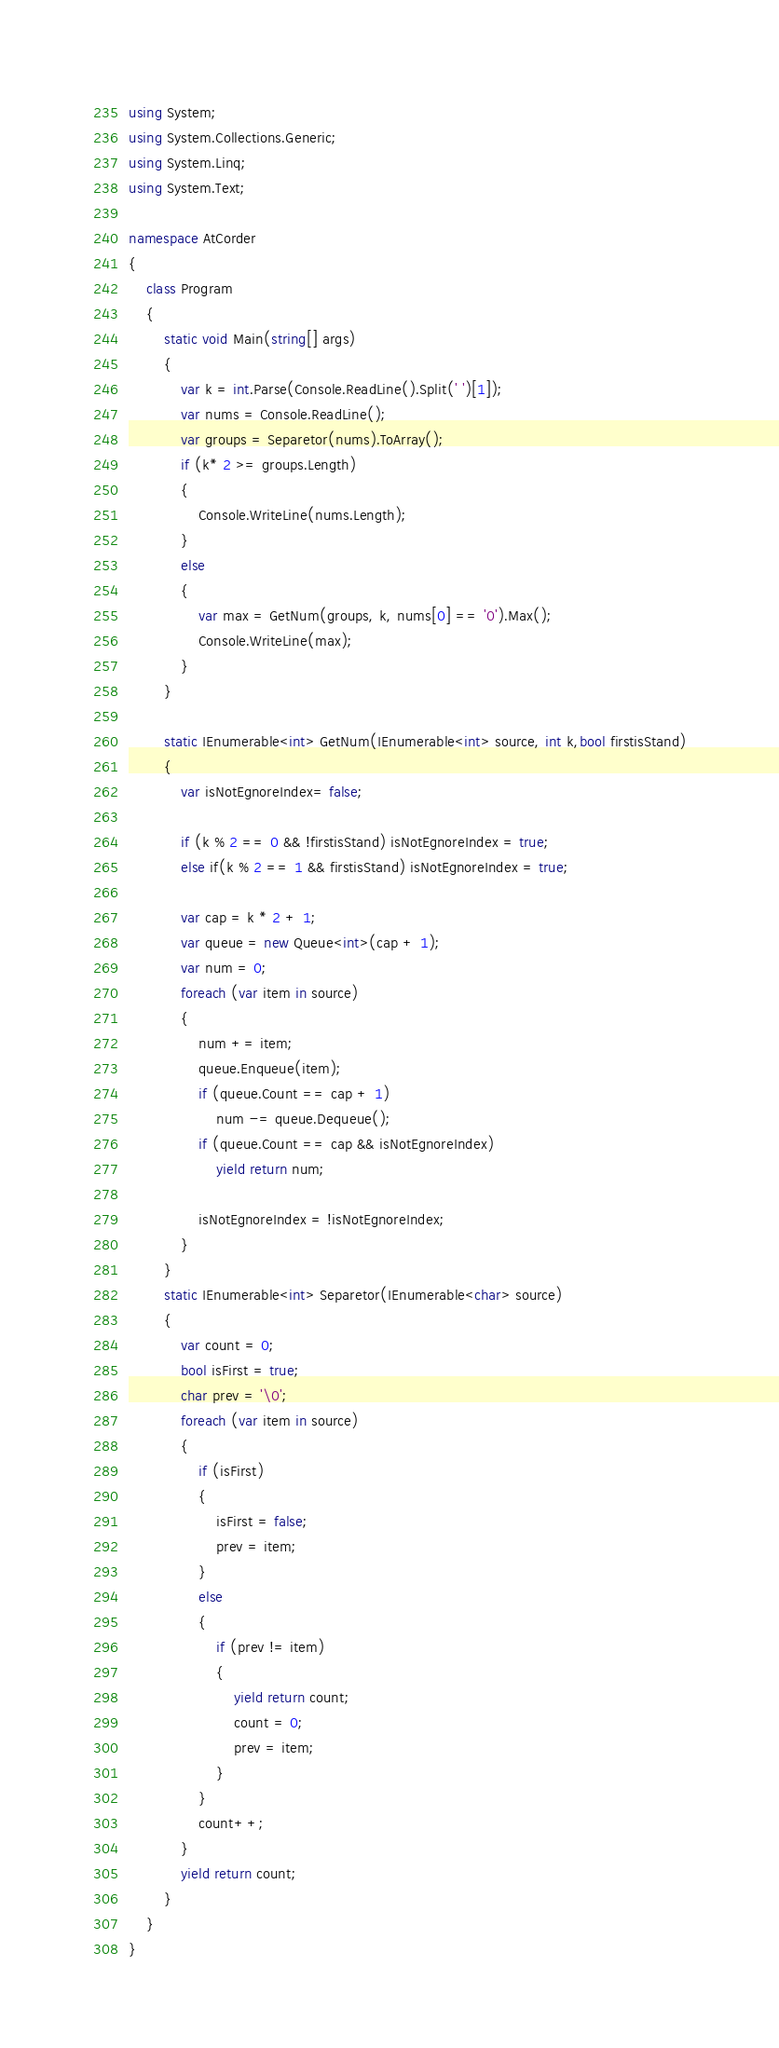<code> <loc_0><loc_0><loc_500><loc_500><_C#_>using System;
using System.Collections.Generic;
using System.Linq;
using System.Text;

namespace AtCorder
{
    class Program
    {
        static void Main(string[] args)
        {
            var k = int.Parse(Console.ReadLine().Split(' ')[1]);
            var nums = Console.ReadLine();
            var groups = Separetor(nums).ToArray();
            if (k* 2 >= groups.Length)
            {
                Console.WriteLine(nums.Length);
            }
            else
            {
                var max = GetNum(groups, k, nums[0] == '0').Max();
                Console.WriteLine(max);
            }
        }

        static IEnumerable<int> GetNum(IEnumerable<int> source, int k,bool firstisStand)
        {
            var isNotEgnoreIndex= false;

            if (k % 2 == 0 && !firstisStand) isNotEgnoreIndex = true;
            else if(k % 2 == 1 && firstisStand) isNotEgnoreIndex = true;

            var cap = k * 2 + 1;
            var queue = new Queue<int>(cap + 1);
            var num = 0;
            foreach (var item in source)
            {
                num += item;
                queue.Enqueue(item);
                if (queue.Count == cap + 1)
                    num -= queue.Dequeue();
                if (queue.Count == cap && isNotEgnoreIndex)
                    yield return num;

                isNotEgnoreIndex = !isNotEgnoreIndex;
            }
        }
        static IEnumerable<int> Separetor(IEnumerable<char> source)
        {
            var count = 0;
            bool isFirst = true;
            char prev = '\0';
            foreach (var item in source)
            {
                if (isFirst)
                {
                    isFirst = false;
                    prev = item;
                }
                else
                {
                    if (prev != item)
                    {
                        yield return count;
                        count = 0;
                        prev = item;
                    }
                }
                count++;
            }
            yield return count;
        }
    }
}
</code> 